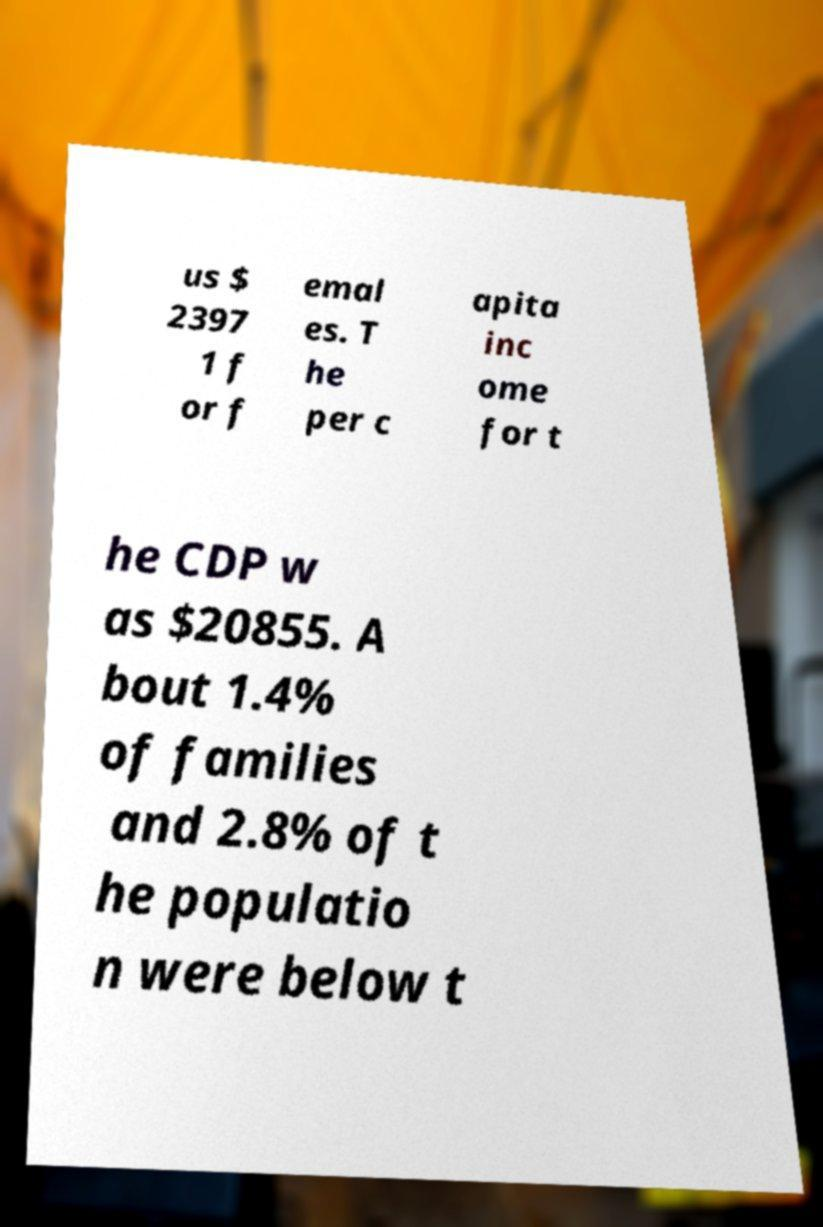I need the written content from this picture converted into text. Can you do that? us $ 2397 1 f or f emal es. T he per c apita inc ome for t he CDP w as $20855. A bout 1.4% of families and 2.8% of t he populatio n were below t 